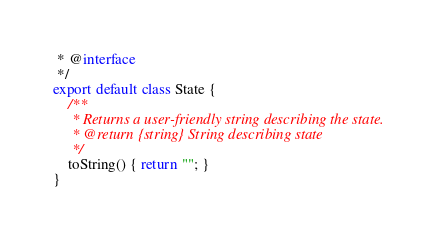Convert code to text. <code><loc_0><loc_0><loc_500><loc_500><_JavaScript_> * @interface
 */
export default class State {
    /**
     * Returns a user-friendly string describing the state.
     * @return {string} String describing state
     */
    toString() { return ""; }
}
</code> 